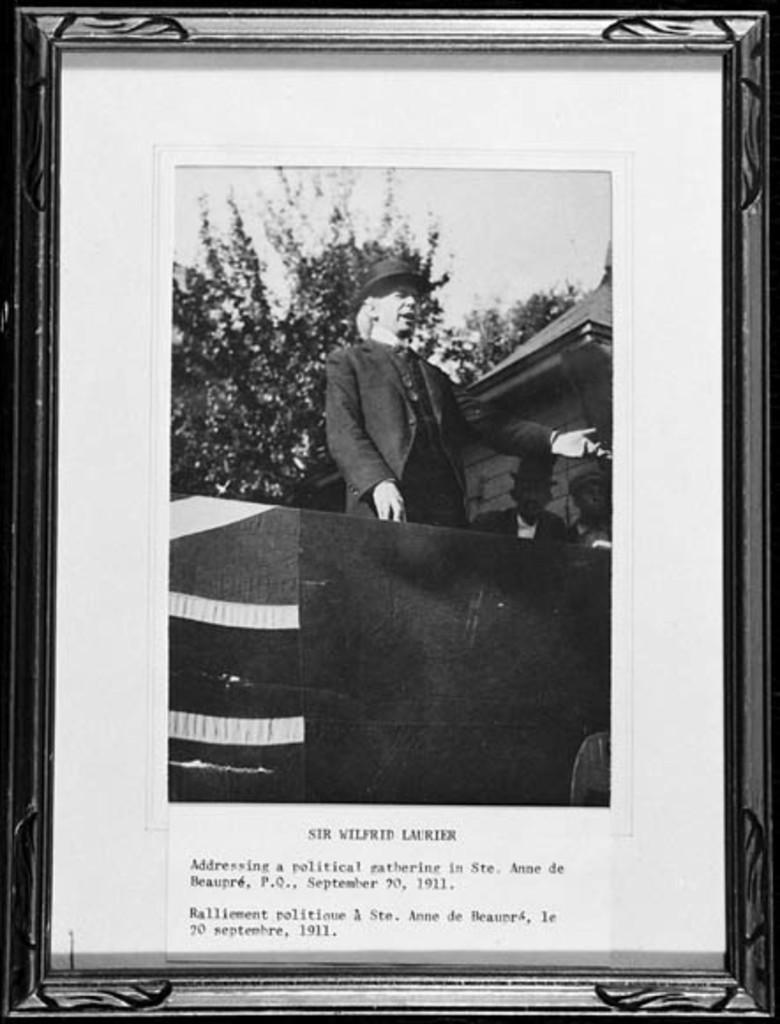<image>
Describe the image concisely. A photo of a man in a top hat is in a frame that says Sir Wilfrid Laurier. 